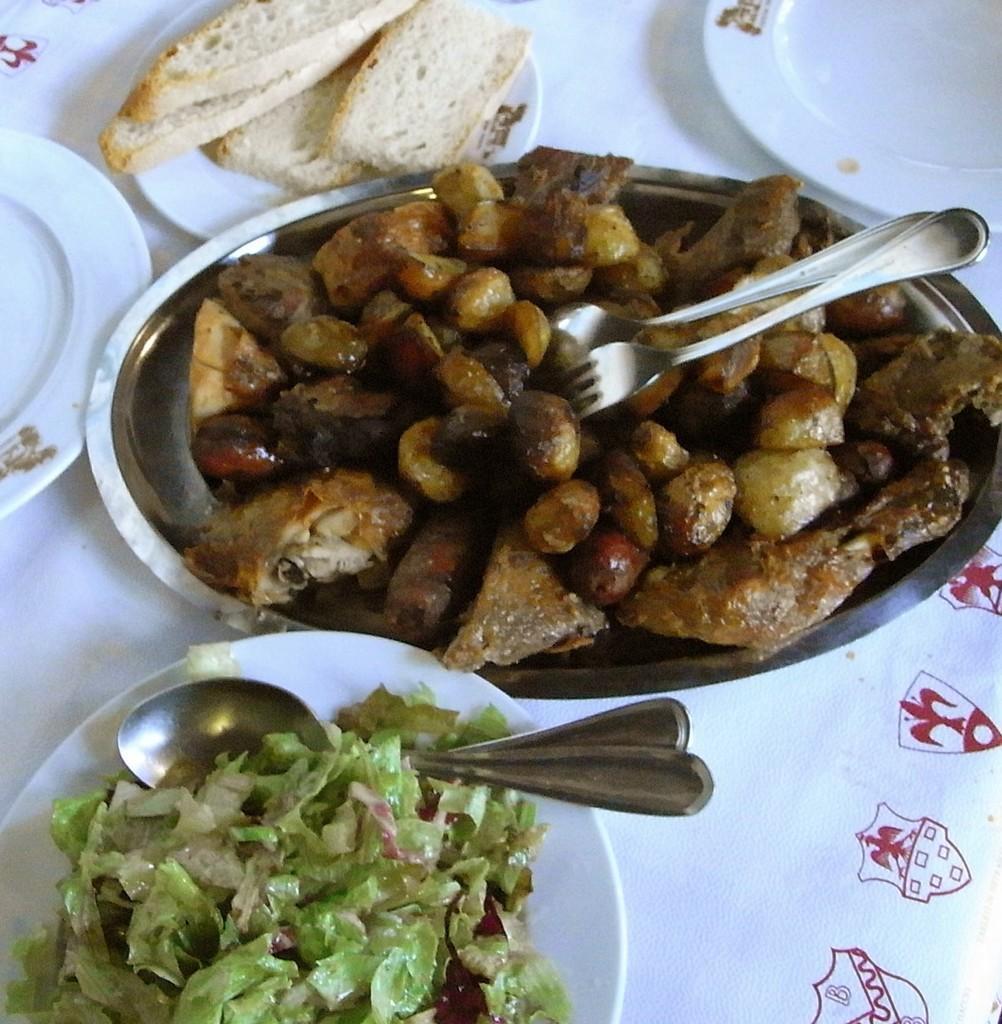In one or two sentences, can you explain what this image depicts? Here in this picture we can see a table, on which we can see number of plates with food items and vegetables and bread slices present on it and we can also see spoons and forks also present. 